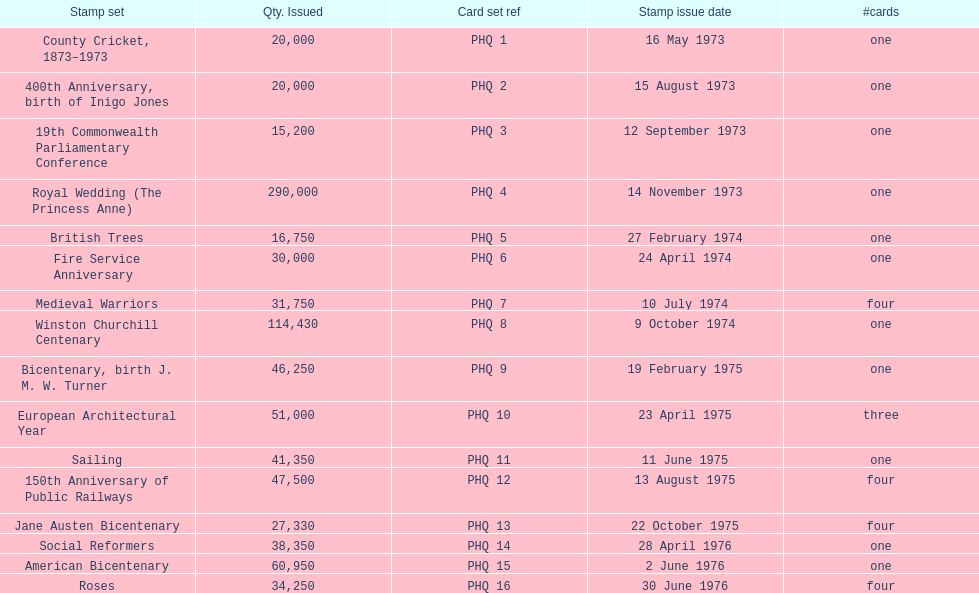List each bicentenary stamp set Bicentenary, birth J. M. W. Turner, Jane Austen Bicentenary, American Bicentenary. 